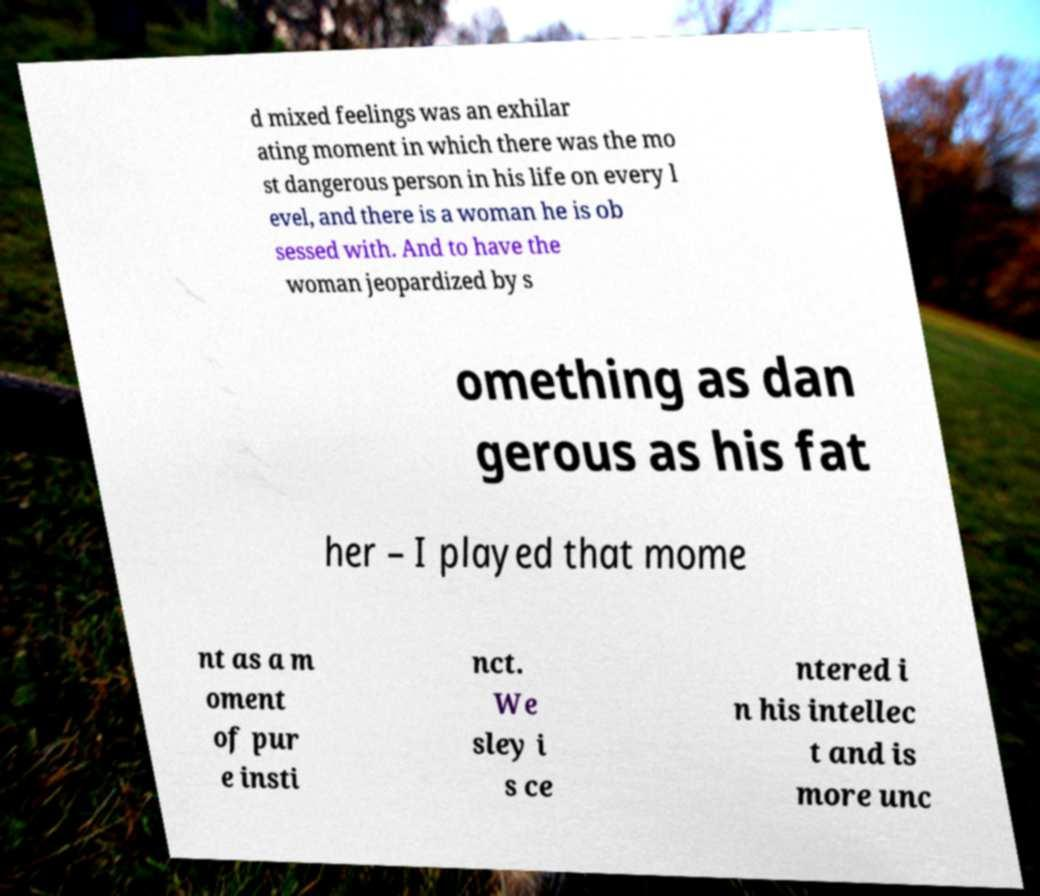Please identify and transcribe the text found in this image. d mixed feelings was an exhilar ating moment in which there was the mo st dangerous person in his life on every l evel, and there is a woman he is ob sessed with. And to have the woman jeopardized by s omething as dan gerous as his fat her – I played that mome nt as a m oment of pur e insti nct. We sley i s ce ntered i n his intellec t and is more unc 